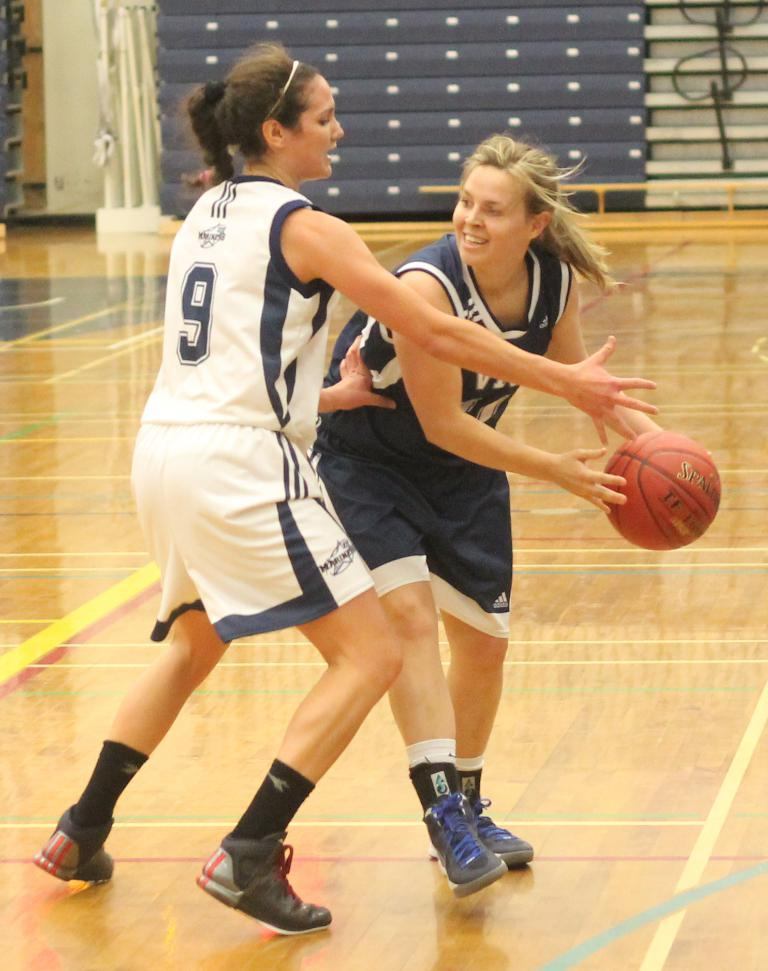<image>
Present a compact description of the photo's key features. Basketball player wearing jersey number 9 playing defense on another player. 